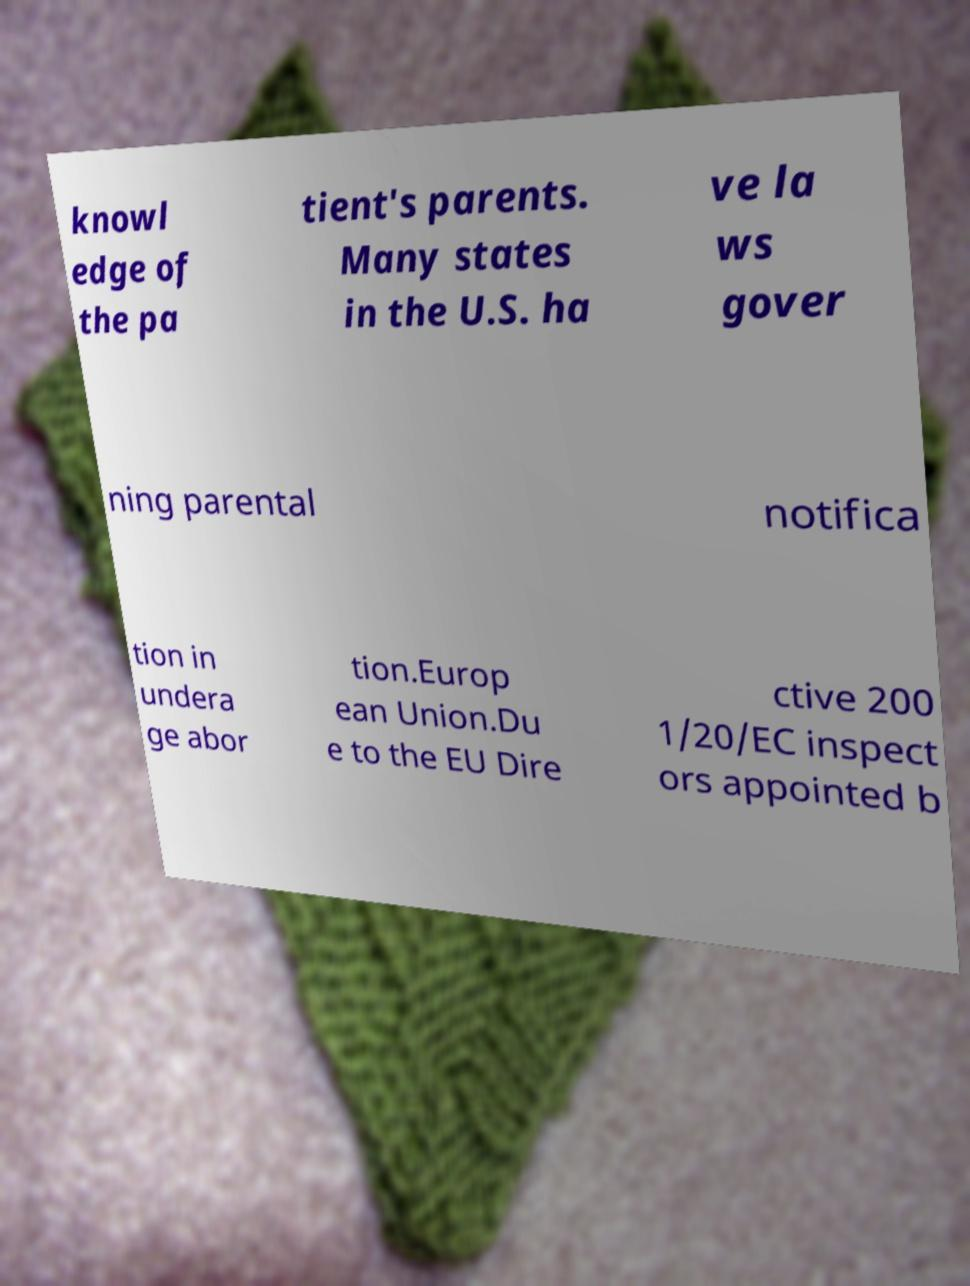Could you assist in decoding the text presented in this image and type it out clearly? knowl edge of the pa tient's parents. Many states in the U.S. ha ve la ws gover ning parental notifica tion in undera ge abor tion.Europ ean Union.Du e to the EU Dire ctive 200 1/20/EC inspect ors appointed b 